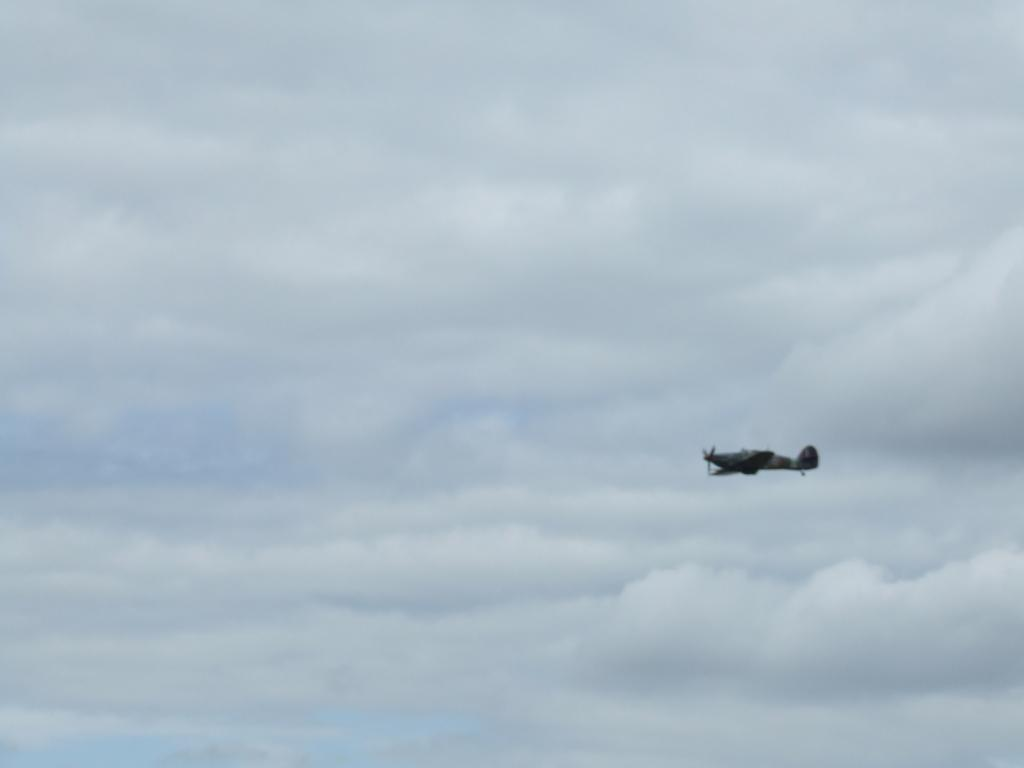What is the main subject of the image? The main subject of the image is an aircraft. Where is the aircraft located in the image? The aircraft is on the right side of the image. What can be seen in the background of the image? There are clouds and the sky visible in the background of the image. What type of guitar can be seen in the image? There is no guitar present in the image; it features an aircraft and a background with clouds and the sky. 